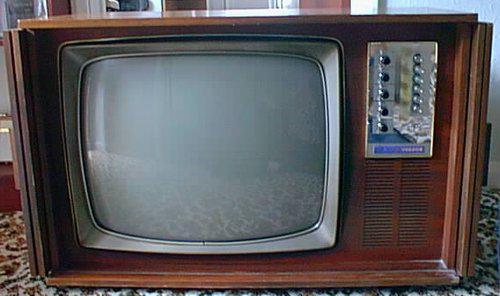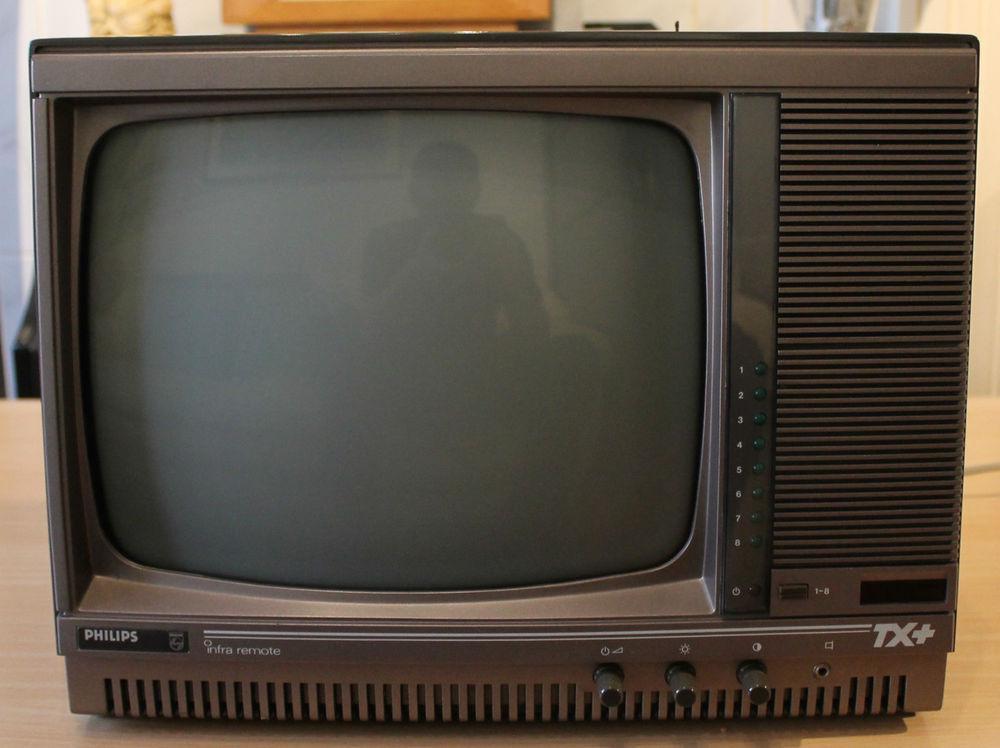The first image is the image on the left, the second image is the image on the right. Examine the images to the left and right. Is the description "The right image contains a TV with a reddish-orange case and two large dials to the right of its screen." accurate? Answer yes or no. No. The first image is the image on the left, the second image is the image on the right. Assess this claim about the two images: "In one of the images there is a red television with rotary knobs.". Correct or not? Answer yes or no. No. 